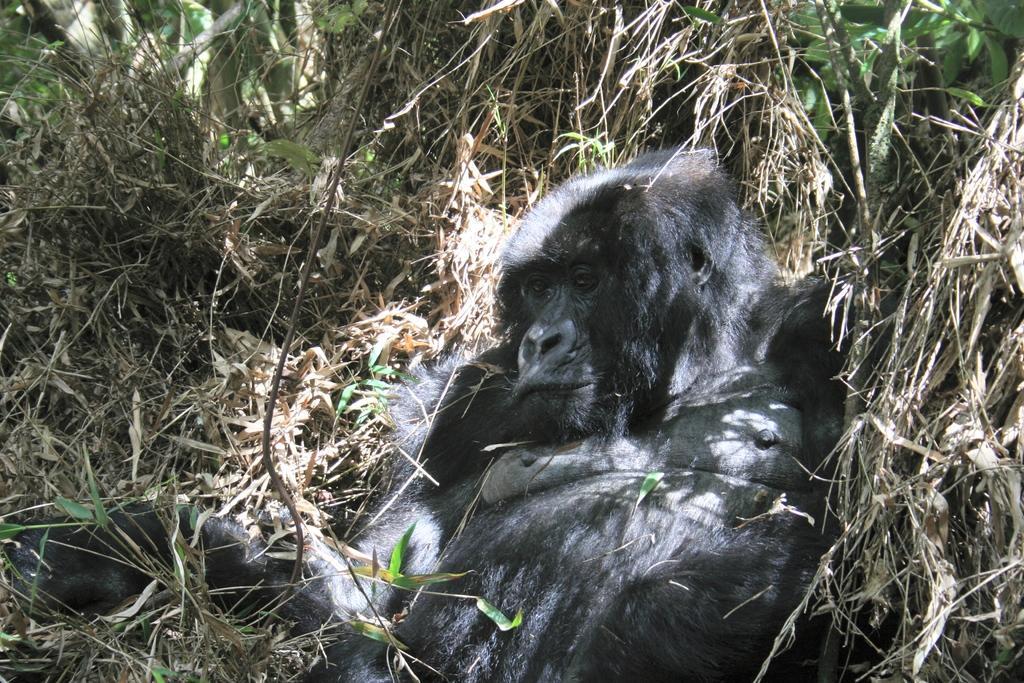How would you summarize this image in a sentence or two? In the picture I can see a gorilla lying on the dry grass. Here we can see plants. 